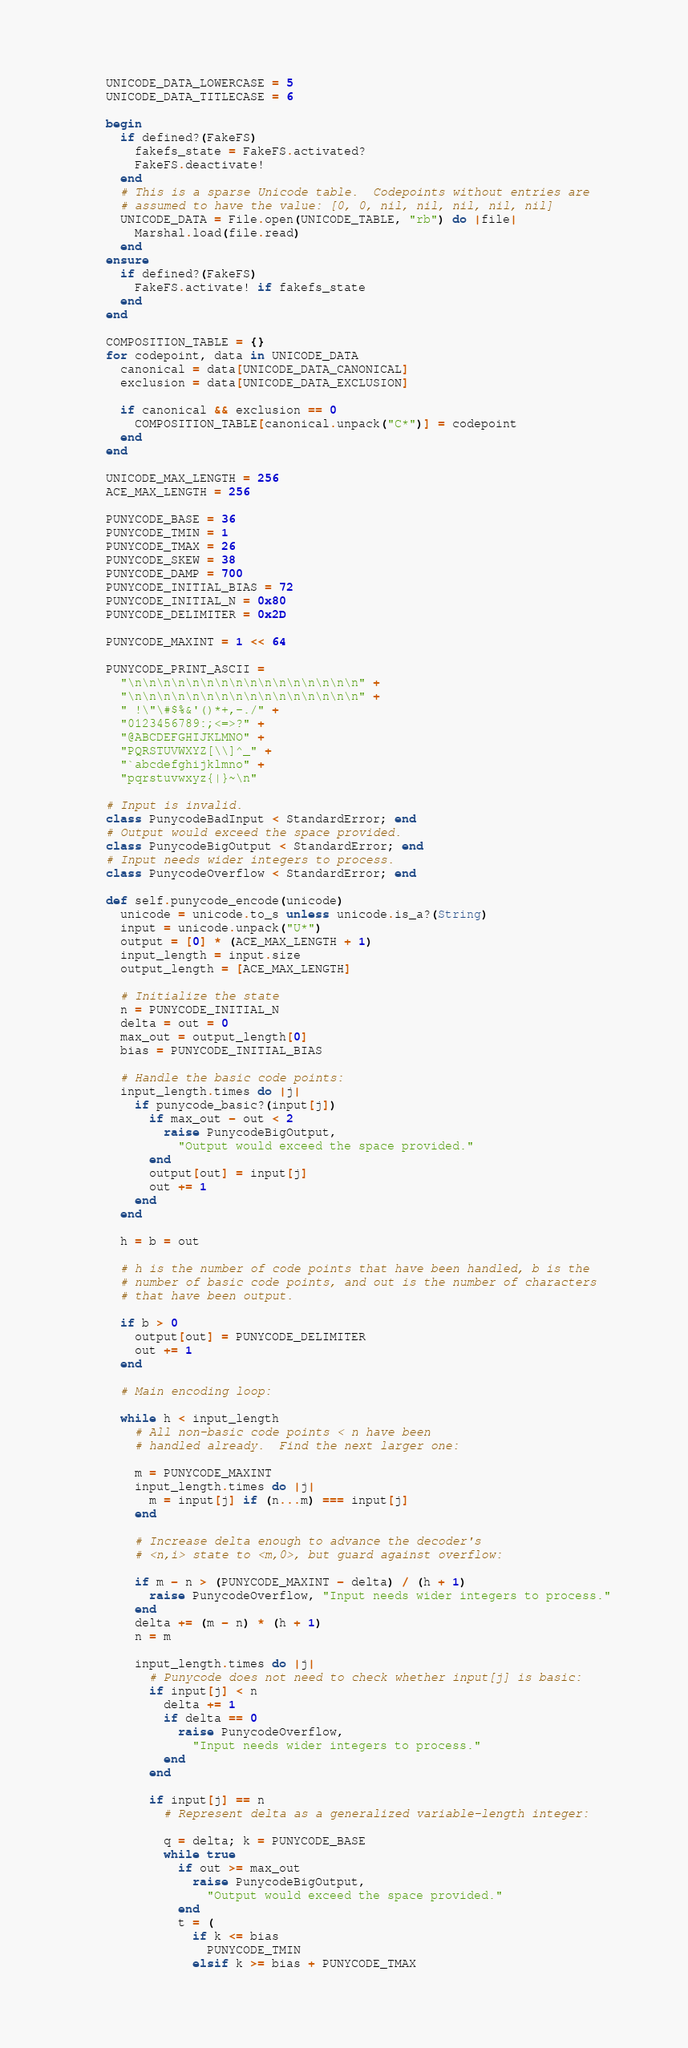Convert code to text. <code><loc_0><loc_0><loc_500><loc_500><_Ruby_>    UNICODE_DATA_LOWERCASE = 5
    UNICODE_DATA_TITLECASE = 6

    begin
      if defined?(FakeFS)
        fakefs_state = FakeFS.activated?
        FakeFS.deactivate!
      end
      # This is a sparse Unicode table.  Codepoints without entries are
      # assumed to have the value: [0, 0, nil, nil, nil, nil, nil]
      UNICODE_DATA = File.open(UNICODE_TABLE, "rb") do |file|
        Marshal.load(file.read)
      end
    ensure
      if defined?(FakeFS)
        FakeFS.activate! if fakefs_state
      end
    end

    COMPOSITION_TABLE = {}
    for codepoint, data in UNICODE_DATA
      canonical = data[UNICODE_DATA_CANONICAL]
      exclusion = data[UNICODE_DATA_EXCLUSION]

      if canonical && exclusion == 0
        COMPOSITION_TABLE[canonical.unpack("C*")] = codepoint
      end
    end

    UNICODE_MAX_LENGTH = 256
    ACE_MAX_LENGTH = 256

    PUNYCODE_BASE = 36
    PUNYCODE_TMIN = 1
    PUNYCODE_TMAX = 26
    PUNYCODE_SKEW = 38
    PUNYCODE_DAMP = 700
    PUNYCODE_INITIAL_BIAS = 72
    PUNYCODE_INITIAL_N = 0x80
    PUNYCODE_DELIMITER = 0x2D

    PUNYCODE_MAXINT = 1 << 64

    PUNYCODE_PRINT_ASCII =
      "\n\n\n\n\n\n\n\n\n\n\n\n\n\n\n\n" +
      "\n\n\n\n\n\n\n\n\n\n\n\n\n\n\n\n" +
      " !\"\#$%&'()*+,-./" +
      "0123456789:;<=>?" +
      "@ABCDEFGHIJKLMNO" +
      "PQRSTUVWXYZ[\\]^_" +
      "`abcdefghijklmno" +
      "pqrstuvwxyz{|}~\n"

    # Input is invalid.
    class PunycodeBadInput < StandardError; end
    # Output would exceed the space provided.
    class PunycodeBigOutput < StandardError; end
    # Input needs wider integers to process.
    class PunycodeOverflow < StandardError; end

    def self.punycode_encode(unicode)
      unicode = unicode.to_s unless unicode.is_a?(String)
      input = unicode.unpack("U*")
      output = [0] * (ACE_MAX_LENGTH + 1)
      input_length = input.size
      output_length = [ACE_MAX_LENGTH]

      # Initialize the state
      n = PUNYCODE_INITIAL_N
      delta = out = 0
      max_out = output_length[0]
      bias = PUNYCODE_INITIAL_BIAS

      # Handle the basic code points:
      input_length.times do |j|
        if punycode_basic?(input[j])
          if max_out - out < 2
            raise PunycodeBigOutput,
              "Output would exceed the space provided."
          end
          output[out] = input[j]
          out += 1
        end
      end

      h = b = out

      # h is the number of code points that have been handled, b is the
      # number of basic code points, and out is the number of characters
      # that have been output.

      if b > 0
        output[out] = PUNYCODE_DELIMITER
        out += 1
      end

      # Main encoding loop:

      while h < input_length
        # All non-basic code points < n have been
        # handled already.  Find the next larger one:

        m = PUNYCODE_MAXINT
        input_length.times do |j|
          m = input[j] if (n...m) === input[j]
        end

        # Increase delta enough to advance the decoder's
        # <n,i> state to <m,0>, but guard against overflow:

        if m - n > (PUNYCODE_MAXINT - delta) / (h + 1)
          raise PunycodeOverflow, "Input needs wider integers to process."
        end
        delta += (m - n) * (h + 1)
        n = m

        input_length.times do |j|
          # Punycode does not need to check whether input[j] is basic:
          if input[j] < n
            delta += 1
            if delta == 0
              raise PunycodeOverflow,
                "Input needs wider integers to process."
            end
          end

          if input[j] == n
            # Represent delta as a generalized variable-length integer:

            q = delta; k = PUNYCODE_BASE
            while true
              if out >= max_out
                raise PunycodeBigOutput,
                  "Output would exceed the space provided."
              end
              t = (
                if k <= bias
                  PUNYCODE_TMIN
                elsif k >= bias + PUNYCODE_TMAX</code> 